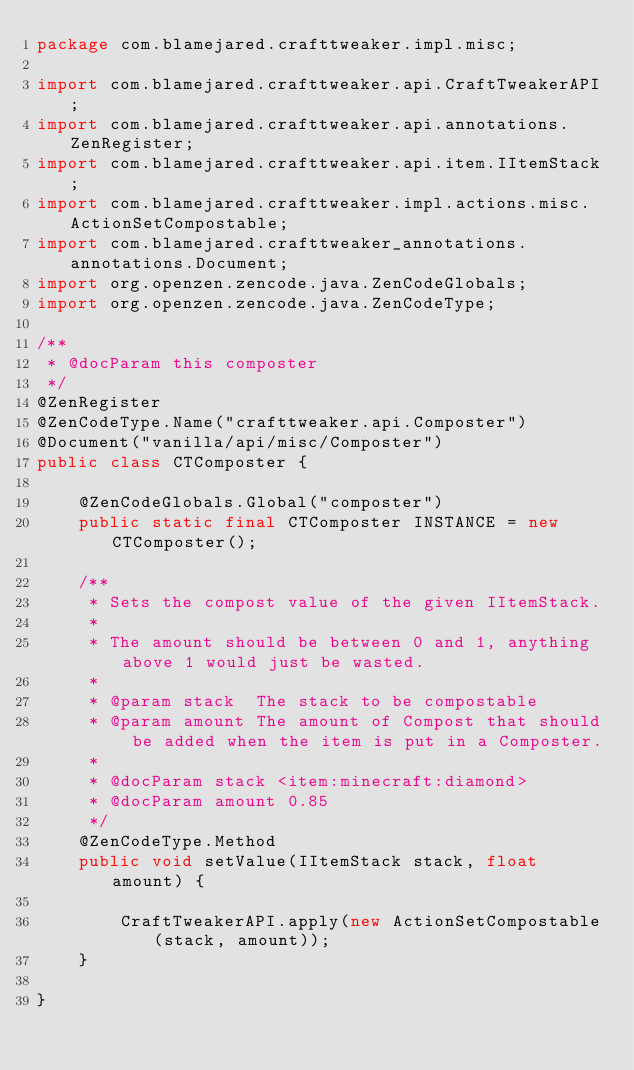Convert code to text. <code><loc_0><loc_0><loc_500><loc_500><_Java_>package com.blamejared.crafttweaker.impl.misc;

import com.blamejared.crafttweaker.api.CraftTweakerAPI;
import com.blamejared.crafttweaker.api.annotations.ZenRegister;
import com.blamejared.crafttweaker.api.item.IItemStack;
import com.blamejared.crafttweaker.impl.actions.misc.ActionSetCompostable;
import com.blamejared.crafttweaker_annotations.annotations.Document;
import org.openzen.zencode.java.ZenCodeGlobals;
import org.openzen.zencode.java.ZenCodeType;

/**
 * @docParam this composter
 */
@ZenRegister
@ZenCodeType.Name("crafttweaker.api.Composter")
@Document("vanilla/api/misc/Composter")
public class CTComposter {
    
    @ZenCodeGlobals.Global("composter")
    public static final CTComposter INSTANCE = new CTComposter();
    
    /**
     * Sets the compost value of the given IItemStack.
     *
     * The amount should be between 0 and 1, anything above 1 would just be wasted.
     *
     * @param stack  The stack to be compostable
     * @param amount The amount of Compost that should be added when the item is put in a Composter.
     *
     * @docParam stack <item:minecraft:diamond>
     * @docParam amount 0.85
     */
    @ZenCodeType.Method
    public void setValue(IItemStack stack, float amount) {
        
        CraftTweakerAPI.apply(new ActionSetCompostable(stack, amount));
    }
    
}
</code> 